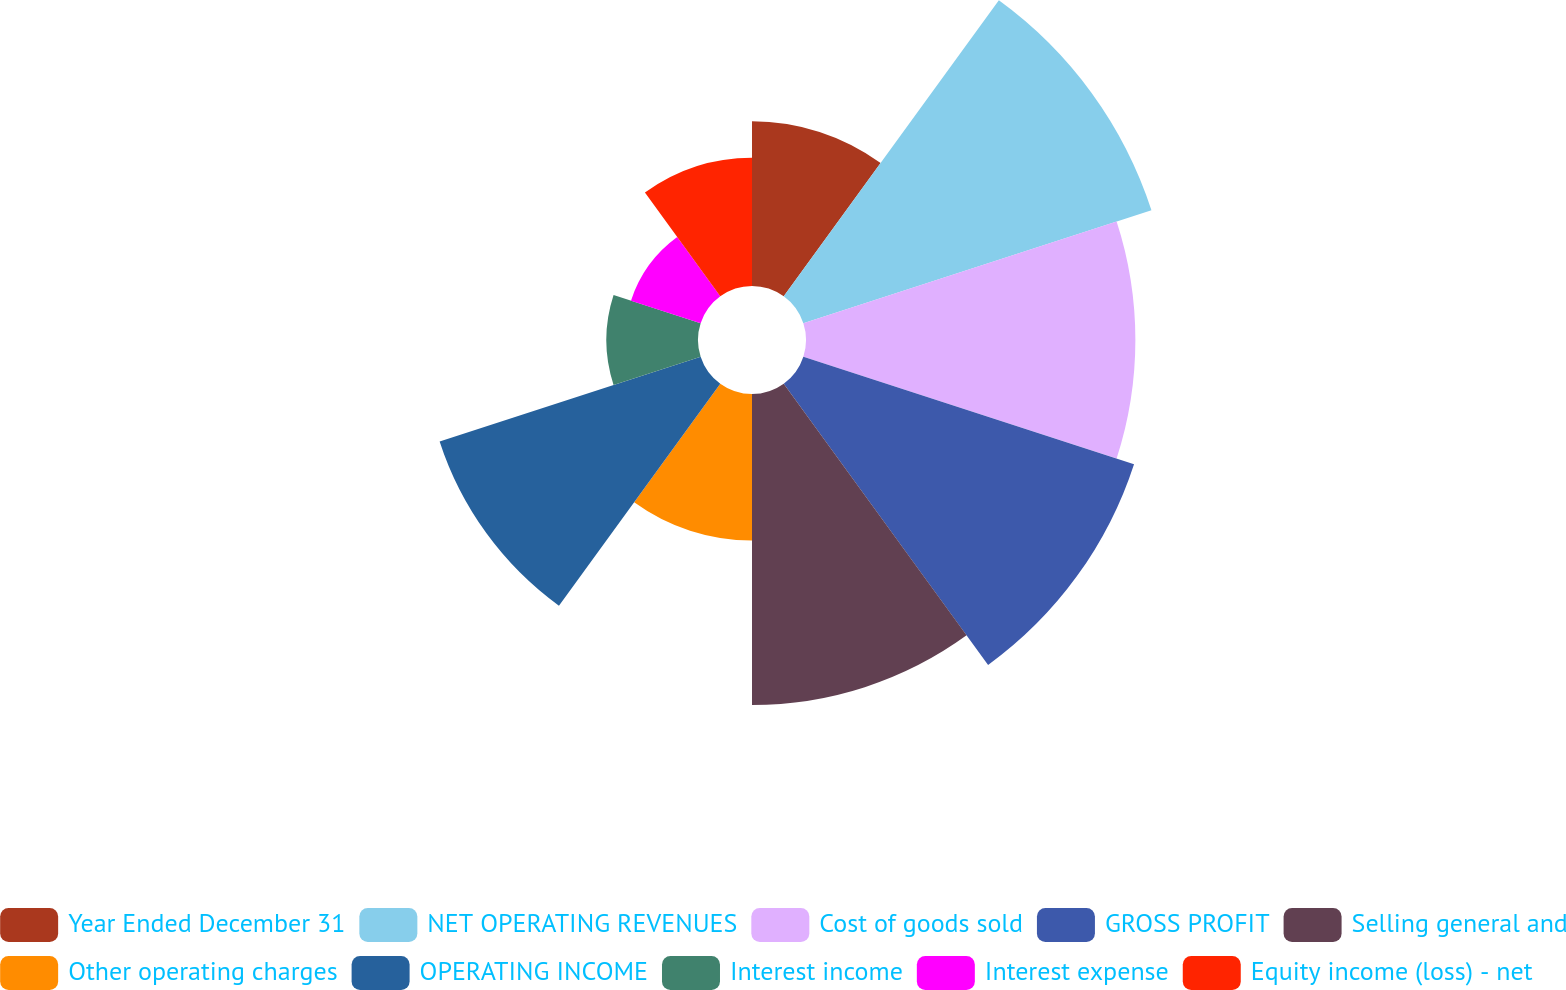Convert chart. <chart><loc_0><loc_0><loc_500><loc_500><pie_chart><fcel>Year Ended December 31<fcel>NET OPERATING REVENUES<fcel>Cost of goods sold<fcel>GROSS PROFIT<fcel>Selling general and<fcel>Other operating charges<fcel>OPERATING INCOME<fcel>Interest income<fcel>Interest expense<fcel>Equity income (loss) - net<nl><fcel>7.38%<fcel>16.39%<fcel>14.75%<fcel>15.57%<fcel>13.93%<fcel>6.56%<fcel>12.29%<fcel>4.1%<fcel>3.28%<fcel>5.74%<nl></chart> 